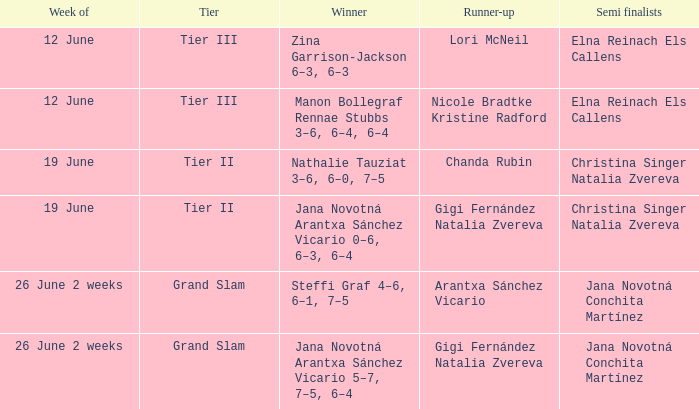Who are the semi finalists on the week of 12 june, when the runner-up is listed as Lori McNeil? Elna Reinach Els Callens. 